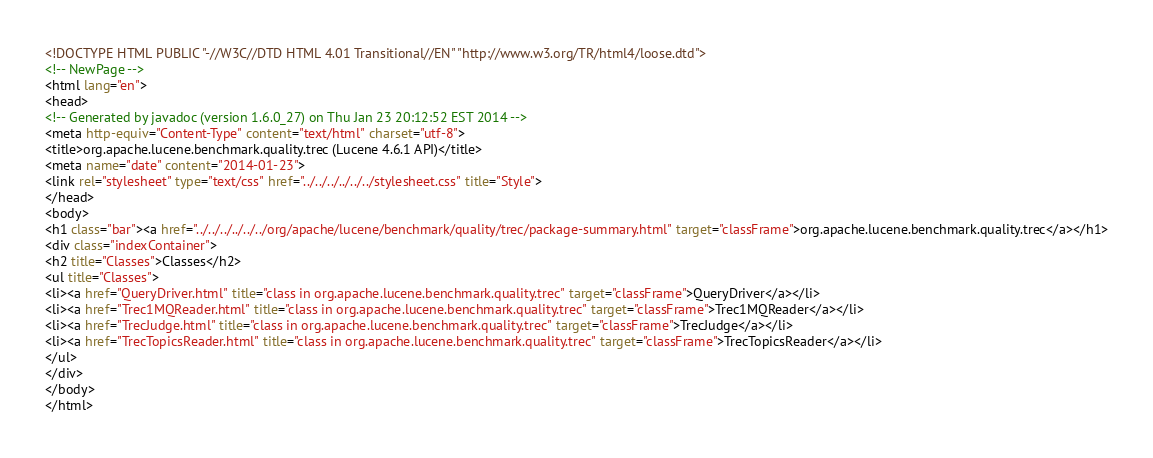Convert code to text. <code><loc_0><loc_0><loc_500><loc_500><_HTML_><!DOCTYPE HTML PUBLIC "-//W3C//DTD HTML 4.01 Transitional//EN" "http://www.w3.org/TR/html4/loose.dtd">
<!-- NewPage -->
<html lang="en">
<head>
<!-- Generated by javadoc (version 1.6.0_27) on Thu Jan 23 20:12:52 EST 2014 -->
<meta http-equiv="Content-Type" content="text/html" charset="utf-8">
<title>org.apache.lucene.benchmark.quality.trec (Lucene 4.6.1 API)</title>
<meta name="date" content="2014-01-23">
<link rel="stylesheet" type="text/css" href="../../../../../../stylesheet.css" title="Style">
</head>
<body>
<h1 class="bar"><a href="../../../../../../org/apache/lucene/benchmark/quality/trec/package-summary.html" target="classFrame">org.apache.lucene.benchmark.quality.trec</a></h1>
<div class="indexContainer">
<h2 title="Classes">Classes</h2>
<ul title="Classes">
<li><a href="QueryDriver.html" title="class in org.apache.lucene.benchmark.quality.trec" target="classFrame">QueryDriver</a></li>
<li><a href="Trec1MQReader.html" title="class in org.apache.lucene.benchmark.quality.trec" target="classFrame">Trec1MQReader</a></li>
<li><a href="TrecJudge.html" title="class in org.apache.lucene.benchmark.quality.trec" target="classFrame">TrecJudge</a></li>
<li><a href="TrecTopicsReader.html" title="class in org.apache.lucene.benchmark.quality.trec" target="classFrame">TrecTopicsReader</a></li>
</ul>
</div>
</body>
</html>
</code> 